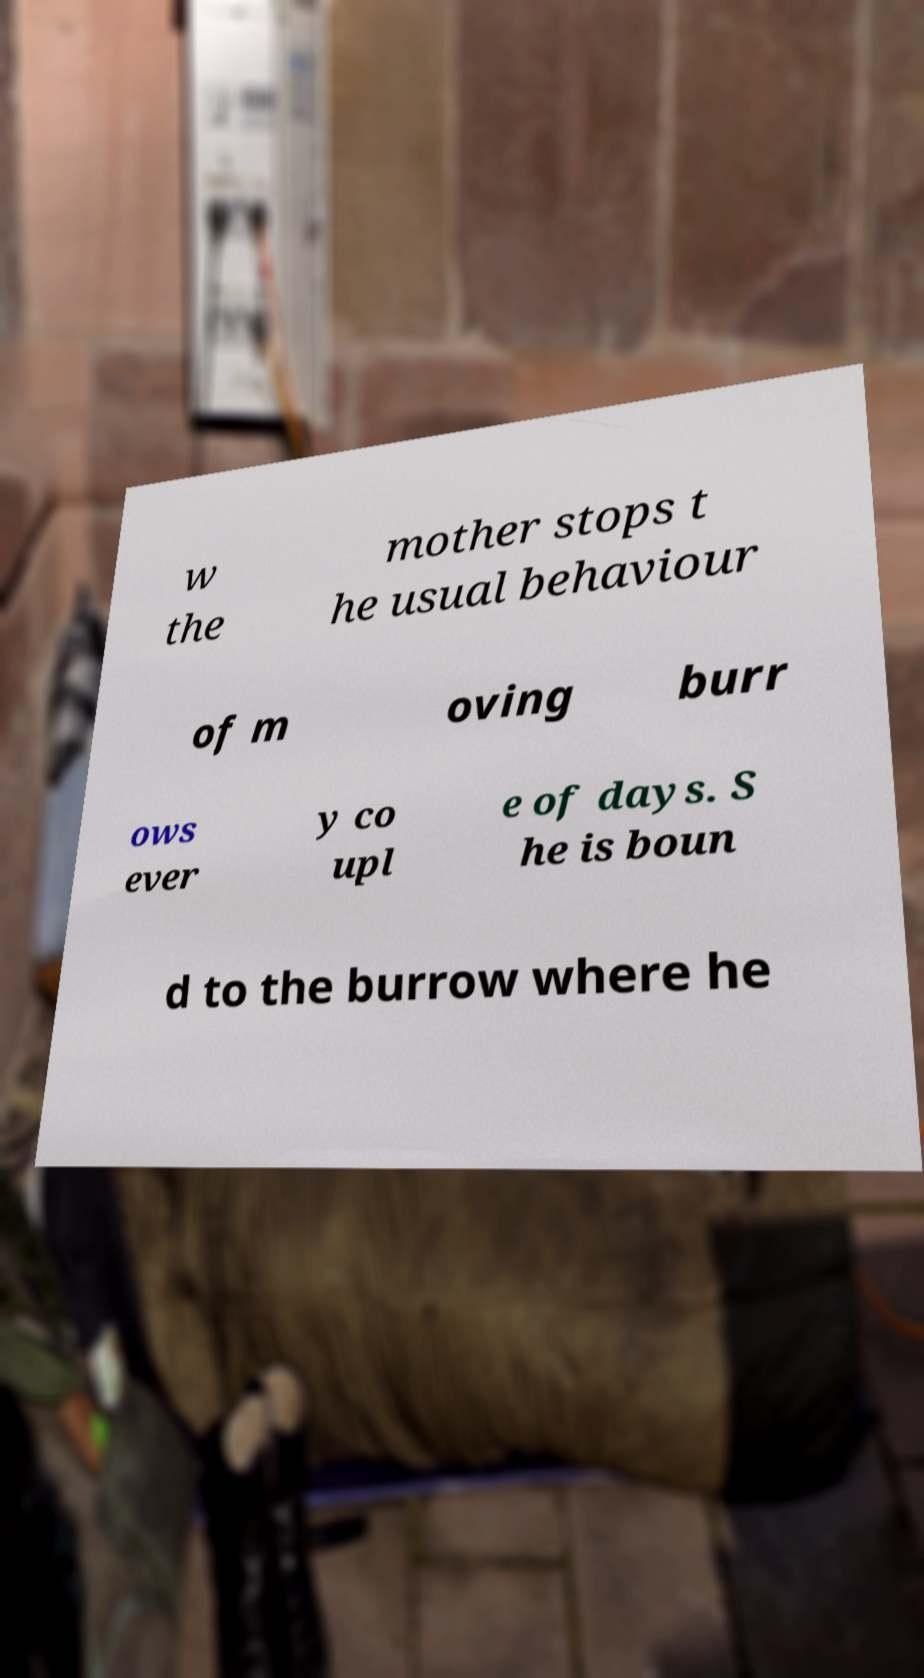I need the written content from this picture converted into text. Can you do that? w the mother stops t he usual behaviour of m oving burr ows ever y co upl e of days. S he is boun d to the burrow where he 